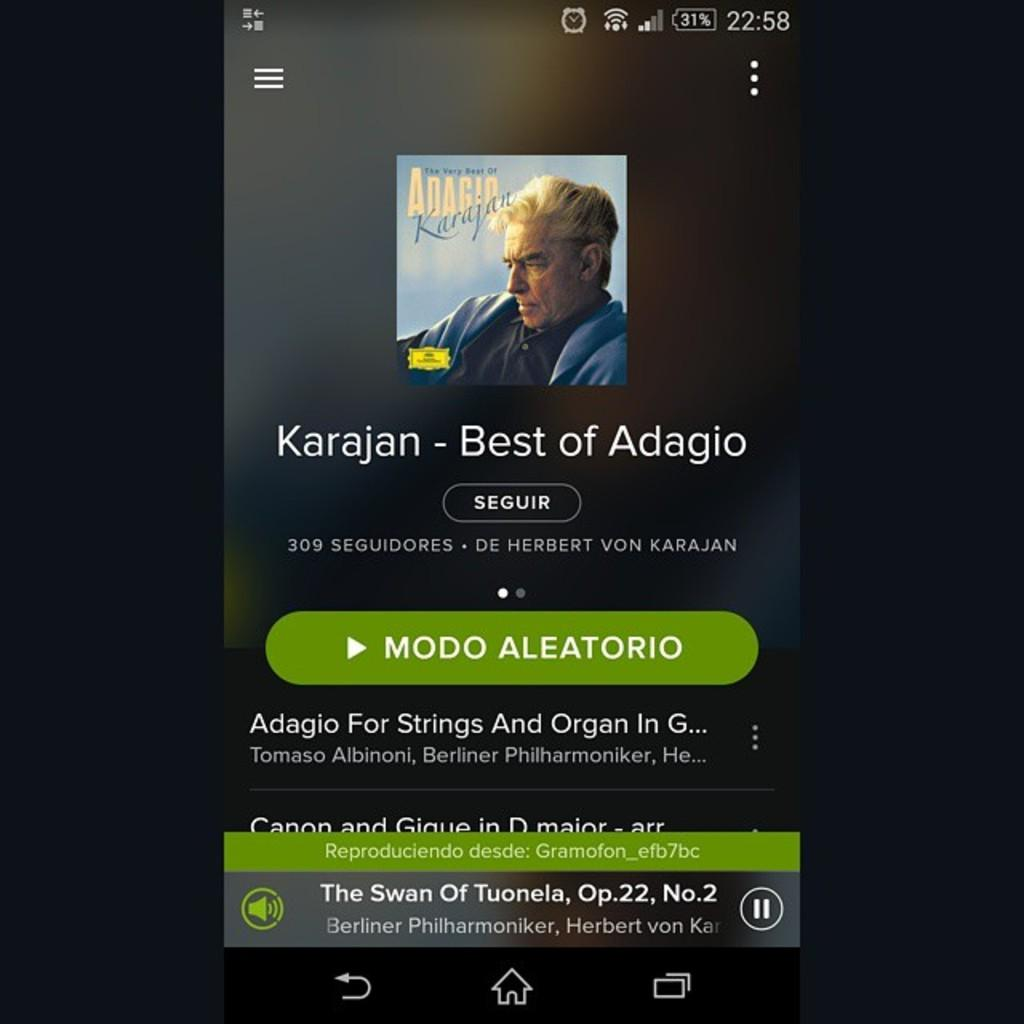<image>
Summarize the visual content of the image. A phone screen shot shows The Swan of Tuonela is being listened to. 